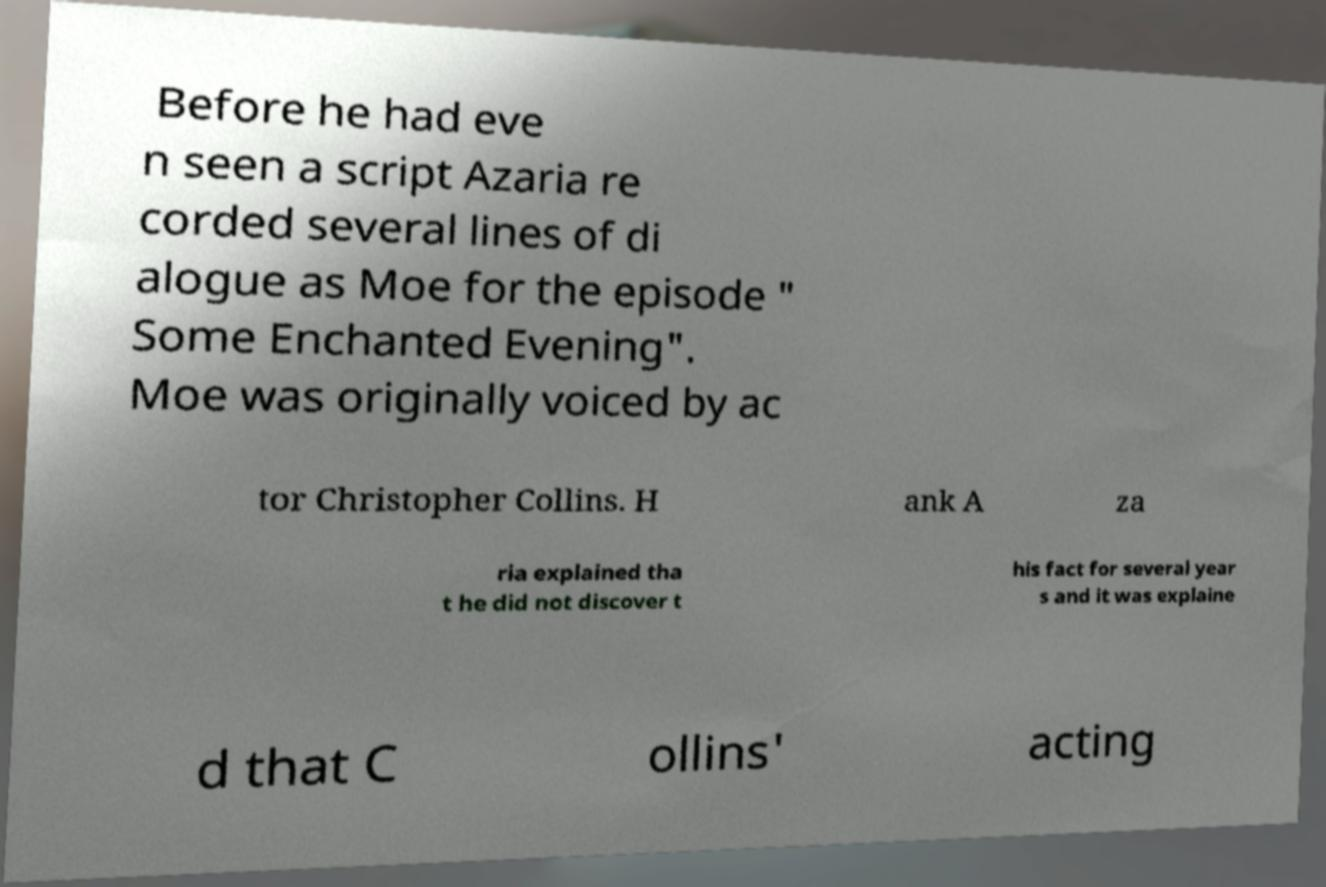There's text embedded in this image that I need extracted. Can you transcribe it verbatim? Before he had eve n seen a script Azaria re corded several lines of di alogue as Moe for the episode " Some Enchanted Evening". Moe was originally voiced by ac tor Christopher Collins. H ank A za ria explained tha t he did not discover t his fact for several year s and it was explaine d that C ollins' acting 